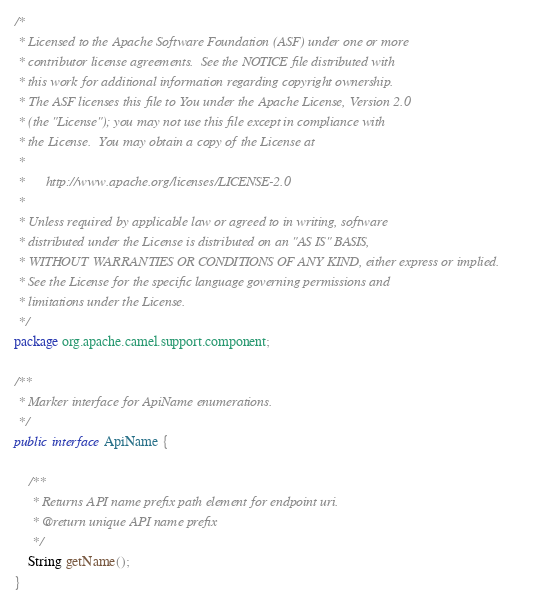<code> <loc_0><loc_0><loc_500><loc_500><_Java_>/*
 * Licensed to the Apache Software Foundation (ASF) under one or more
 * contributor license agreements.  See the NOTICE file distributed with
 * this work for additional information regarding copyright ownership.
 * The ASF licenses this file to You under the Apache License, Version 2.0
 * (the "License"); you may not use this file except in compliance with
 * the License.  You may obtain a copy of the License at
 *
 *      http://www.apache.org/licenses/LICENSE-2.0
 *
 * Unless required by applicable law or agreed to in writing, software
 * distributed under the License is distributed on an "AS IS" BASIS,
 * WITHOUT WARRANTIES OR CONDITIONS OF ANY KIND, either express or implied.
 * See the License for the specific language governing permissions and
 * limitations under the License.
 */
package org.apache.camel.support.component;

/**
 * Marker interface for ApiName enumerations.
 */
public interface ApiName {

    /**
     * Returns API name prefix path element for endpoint uri.
     * @return unique API name prefix
     */
    String getName();
}
</code> 